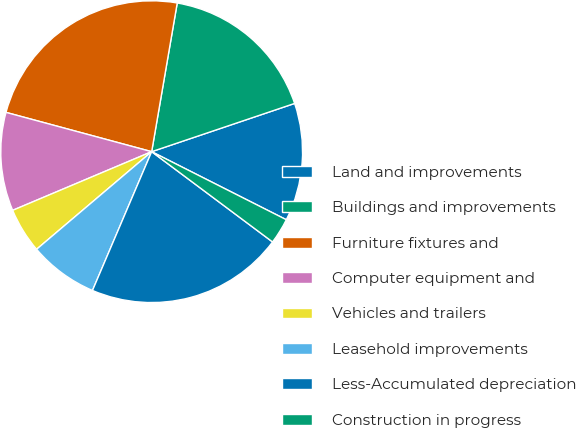Convert chart to OTSL. <chart><loc_0><loc_0><loc_500><loc_500><pie_chart><fcel>Land and improvements<fcel>Buildings and improvements<fcel>Furniture fixtures and<fcel>Computer equipment and<fcel>Vehicles and trailers<fcel>Leasehold improvements<fcel>Less-Accumulated depreciation<fcel>Construction in progress<nl><fcel>12.63%<fcel>17.11%<fcel>23.52%<fcel>10.55%<fcel>4.84%<fcel>7.39%<fcel>21.21%<fcel>2.76%<nl></chart> 